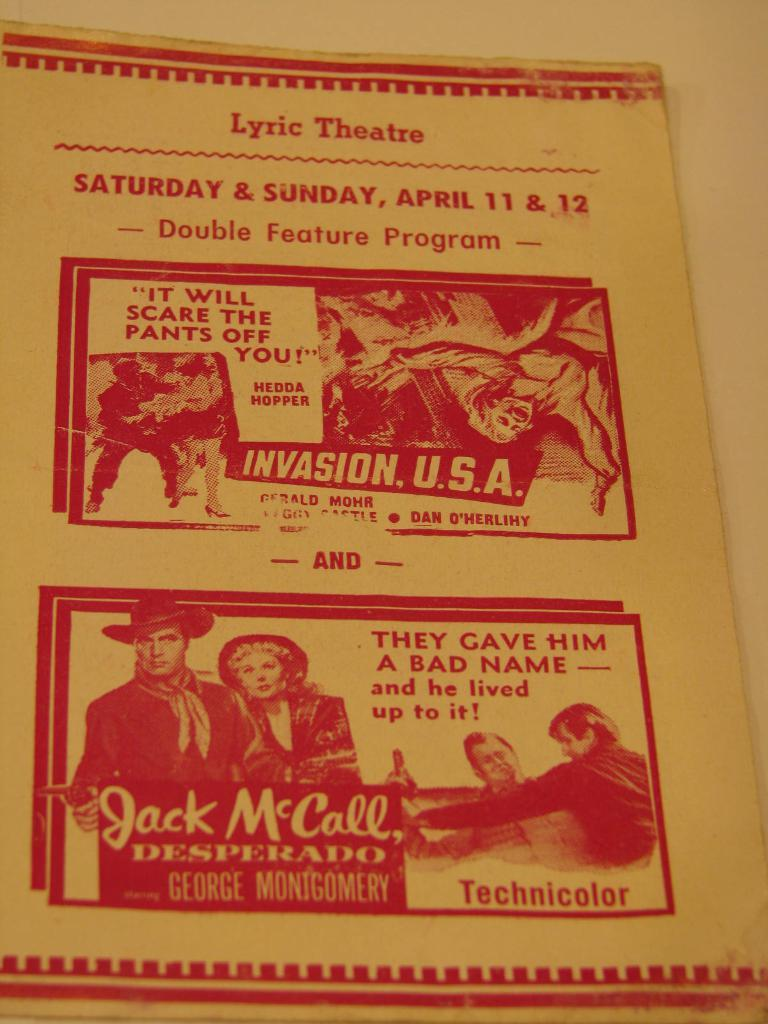<image>
Create a compact narrative representing the image presented. A brochure from the Lyric Theatre for a double feature program of Invasion USA and Jack McCall Desperado. 